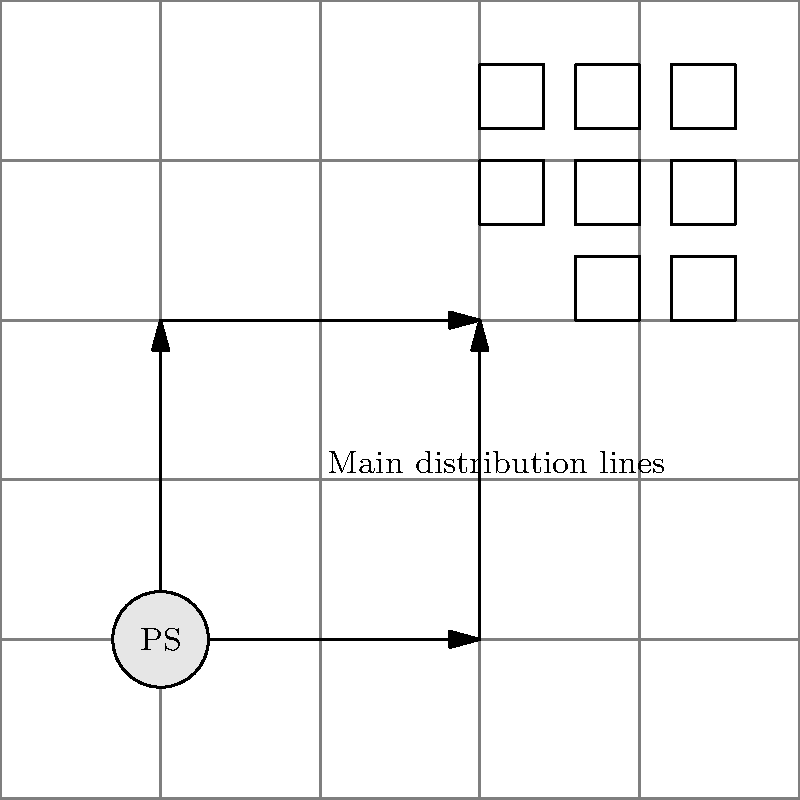In the schematic of Cedar Hill's first electrical power distribution system shown above, what type of distribution network topology is depicted? To determine the type of distribution network topology, let's analyze the schematic step-by-step:

1. We can see a central power station (PS) located at the bottom left of the grid.

2. From the power station, there are two main distribution lines:
   a. One extending horizontally to the right
   b. Another extending vertically upward

3. These main lines intersect at the top right, forming a square-like shape.

4. The houses (represented by small squares) are clustered near the top right corner of this square.

5. This arrangement of power lines forms a closed loop around the area where the houses are located.

6. The power can flow in either direction around this loop, providing multiple paths for electricity to reach each house.

7. This configuration allows for improved reliability, as power can be rerouted in case of a fault on one section of the loop.

Given these observations, the topology depicted is consistent with a ring or loop distribution network. In this type of network, the power lines form a closed circuit, allowing electricity to flow in either direction and providing redundancy in case of faults.
Answer: Ring (or loop) distribution network 